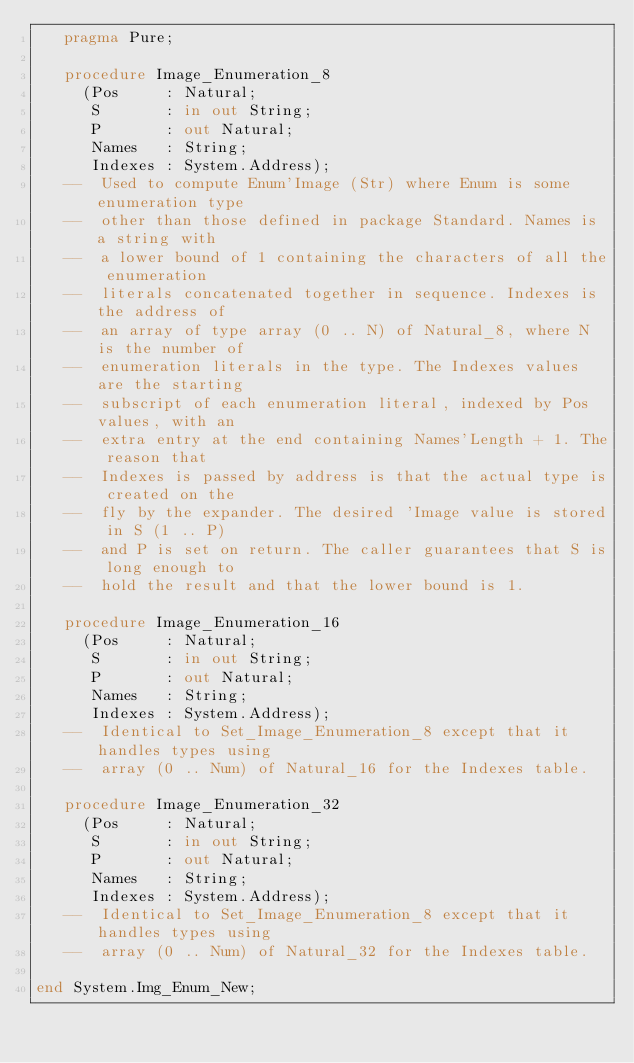<code> <loc_0><loc_0><loc_500><loc_500><_Ada_>   pragma Pure;

   procedure Image_Enumeration_8
     (Pos     : Natural;
      S       : in out String;
      P       : out Natural;
      Names   : String;
      Indexes : System.Address);
   --  Used to compute Enum'Image (Str) where Enum is some enumeration type
   --  other than those defined in package Standard. Names is a string with
   --  a lower bound of 1 containing the characters of all the enumeration
   --  literals concatenated together in sequence. Indexes is the address of
   --  an array of type array (0 .. N) of Natural_8, where N is the number of
   --  enumeration literals in the type. The Indexes values are the starting
   --  subscript of each enumeration literal, indexed by Pos values, with an
   --  extra entry at the end containing Names'Length + 1. The reason that
   --  Indexes is passed by address is that the actual type is created on the
   --  fly by the expander. The desired 'Image value is stored in S (1 .. P)
   --  and P is set on return. The caller guarantees that S is long enough to
   --  hold the result and that the lower bound is 1.

   procedure Image_Enumeration_16
     (Pos     : Natural;
      S       : in out String;
      P       : out Natural;
      Names   : String;
      Indexes : System.Address);
   --  Identical to Set_Image_Enumeration_8 except that it handles types using
   --  array (0 .. Num) of Natural_16 for the Indexes table.

   procedure Image_Enumeration_32
     (Pos     : Natural;
      S       : in out String;
      P       : out Natural;
      Names   : String;
      Indexes : System.Address);
   --  Identical to Set_Image_Enumeration_8 except that it handles types using
   --  array (0 .. Num) of Natural_32 for the Indexes table.

end System.Img_Enum_New;
</code> 